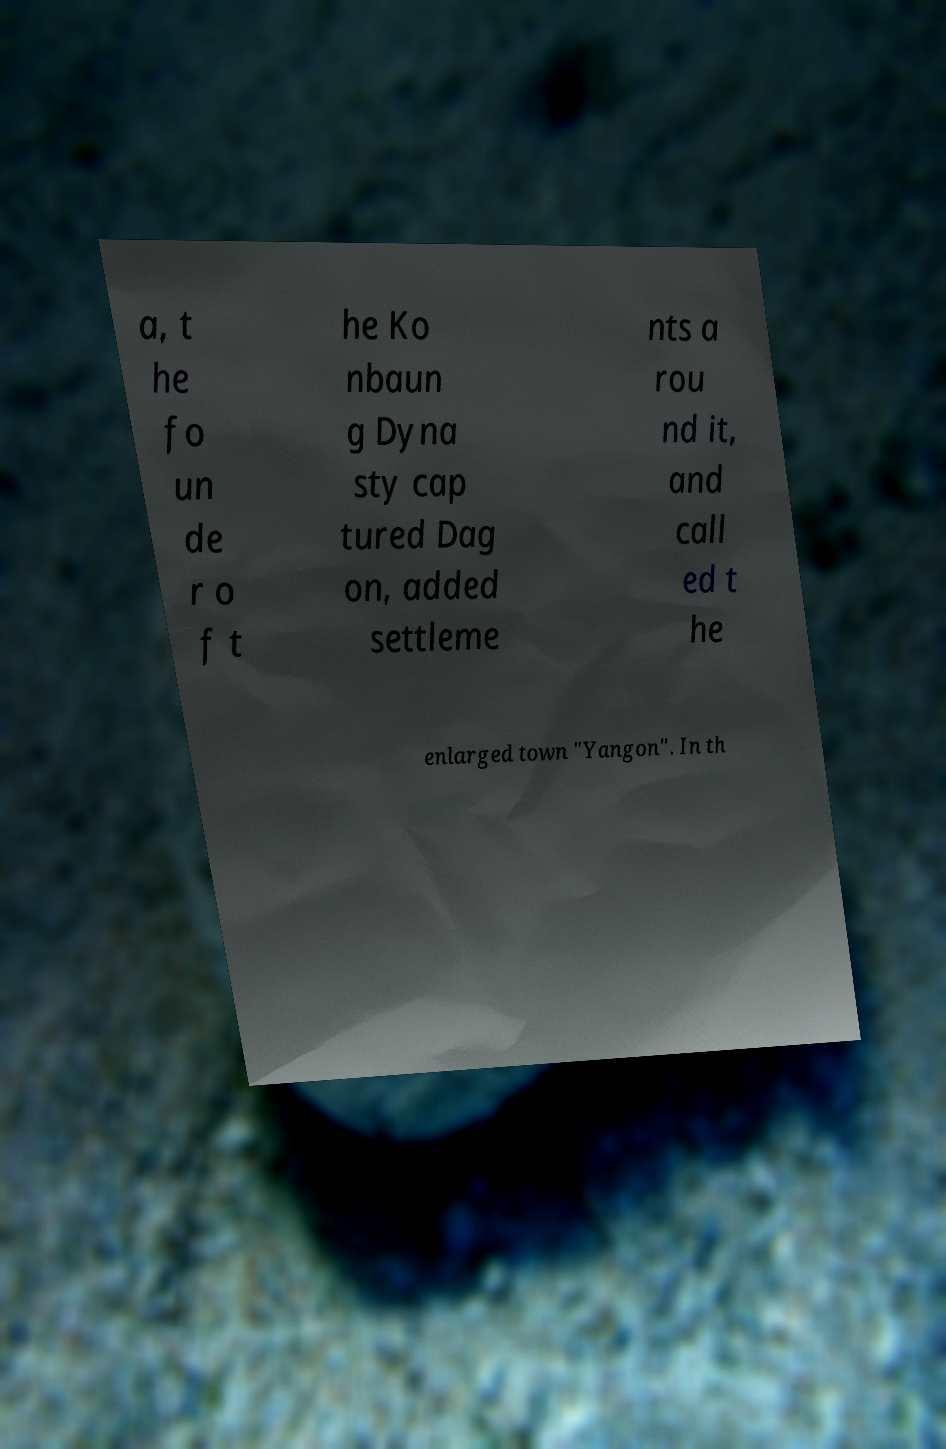Could you extract and type out the text from this image? a, t he fo un de r o f t he Ko nbaun g Dyna sty cap tured Dag on, added settleme nts a rou nd it, and call ed t he enlarged town "Yangon". In th 